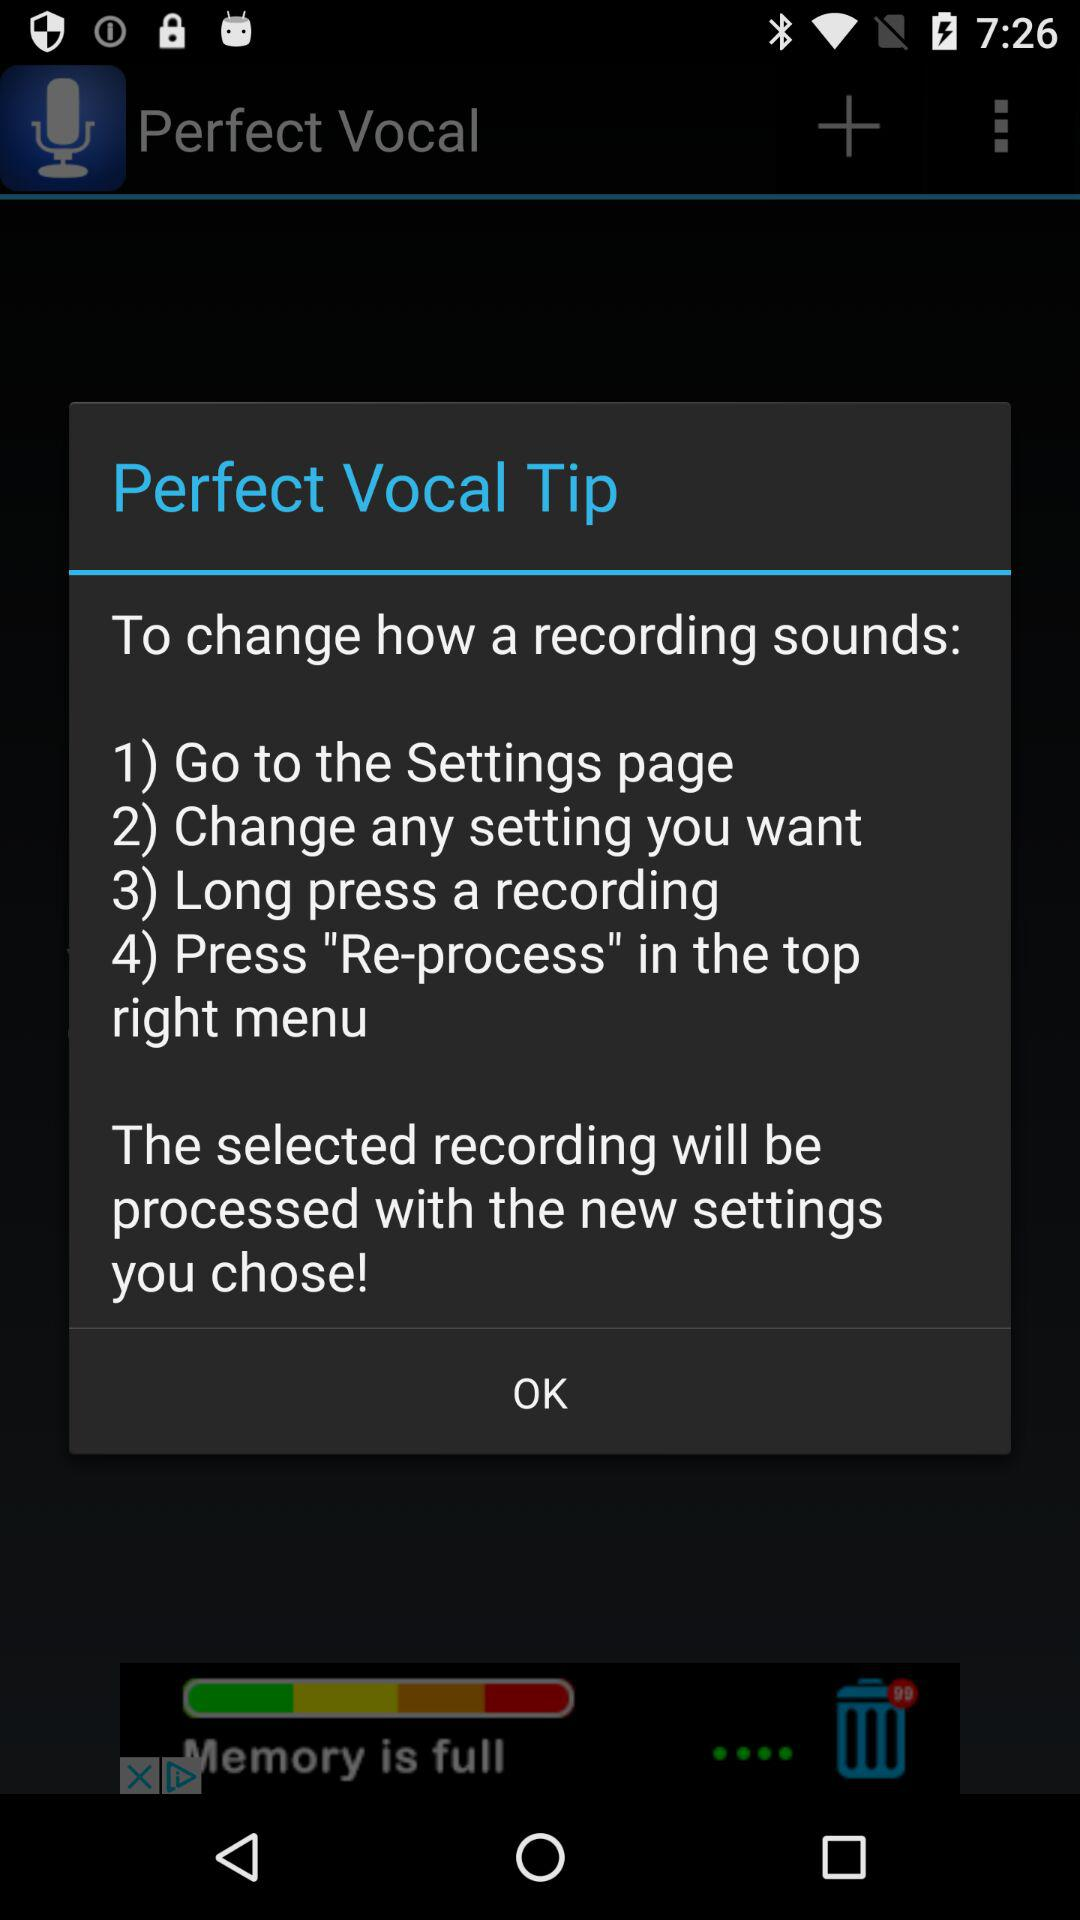How many steps are there in the process of changing how a recording sounds?
Answer the question using a single word or phrase. 4 